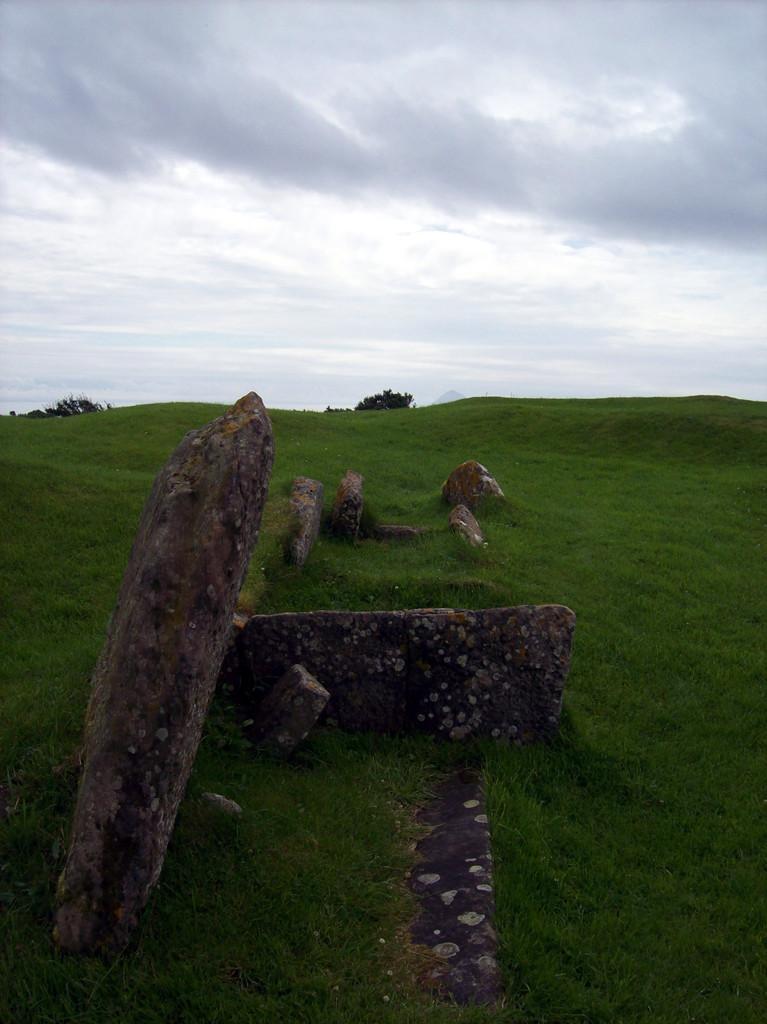Can you describe this image briefly? In this image we can see some rocks, trees, grass, also we can see the sky. 